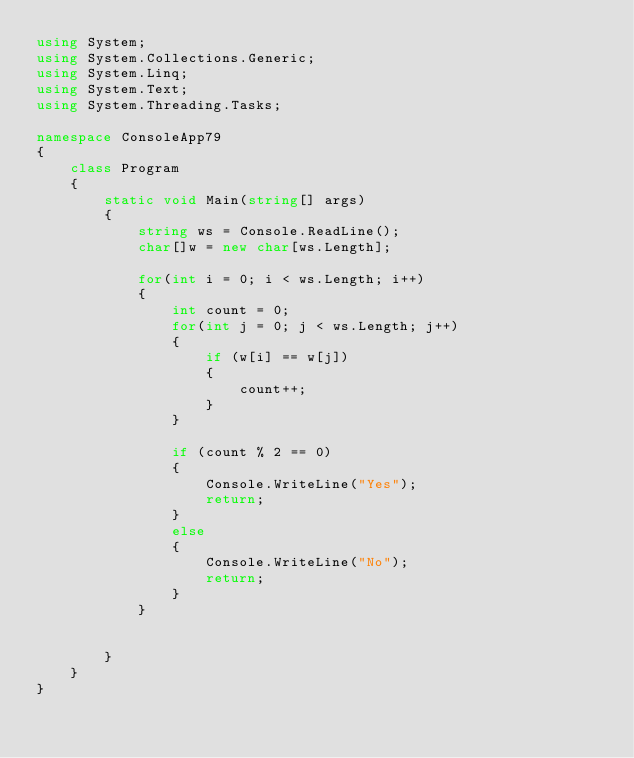Convert code to text. <code><loc_0><loc_0><loc_500><loc_500><_C#_>using System;
using System.Collections.Generic;
using System.Linq;
using System.Text;
using System.Threading.Tasks;

namespace ConsoleApp79
{
    class Program
    {
        static void Main(string[] args)
        {
            string ws = Console.ReadLine();
            char[]w = new char[ws.Length];

            for(int i = 0; i < ws.Length; i++)
            {
                int count = 0;
                for(int j = 0; j < ws.Length; j++)
                {
                    if (w[i] == w[j])
                    {
                        count++;
                    }
                }

                if (count % 2 == 0)
                {
                    Console.WriteLine("Yes");
                    return;
                }
                else
                {
                    Console.WriteLine("No");
                    return;
                }
            }


        }
    }
}
</code> 